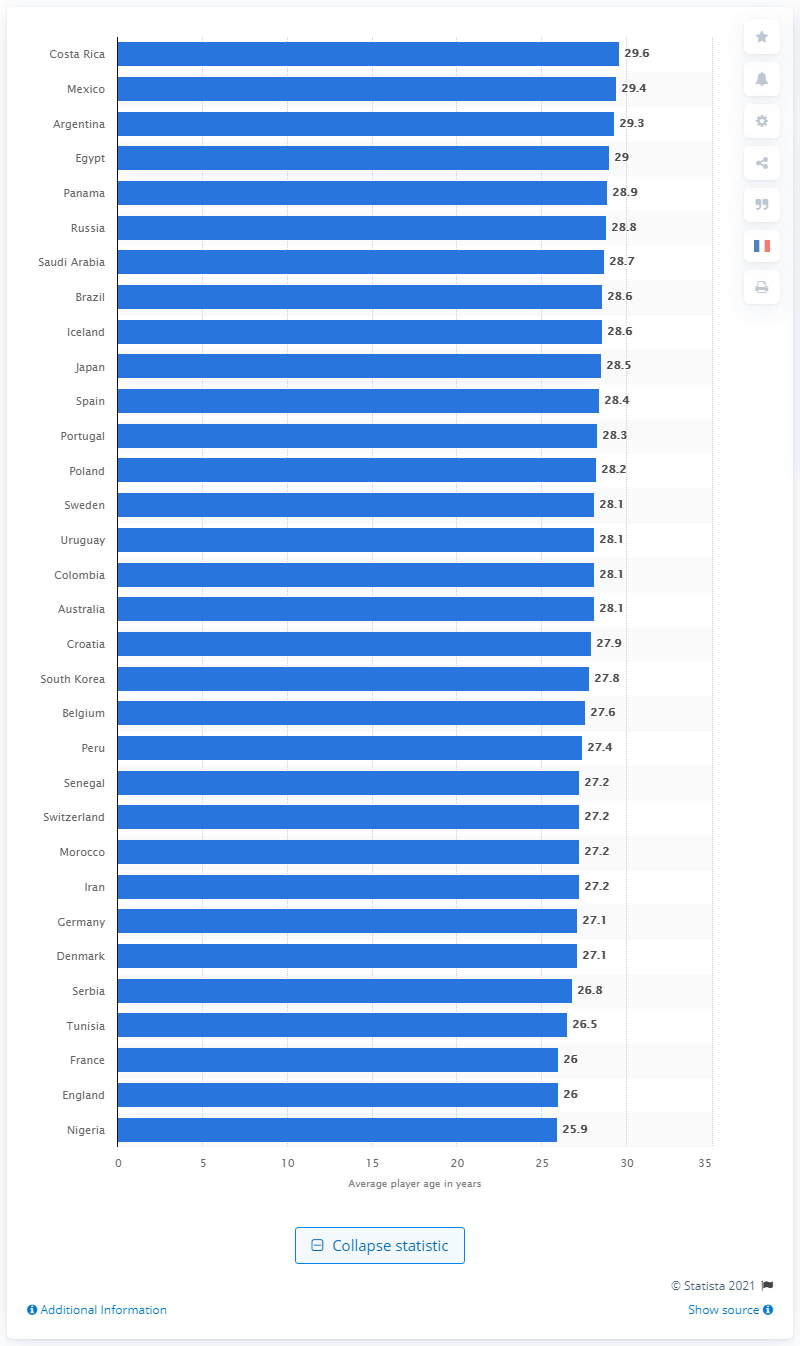Point out several critical features in this image. Nigeria had the youngest squad at the 2018 FIFA World Cup. At the 2018 World Cup, Costa Rica was the oldest average team, with an average age of its players being higher than that of other participating teams. 